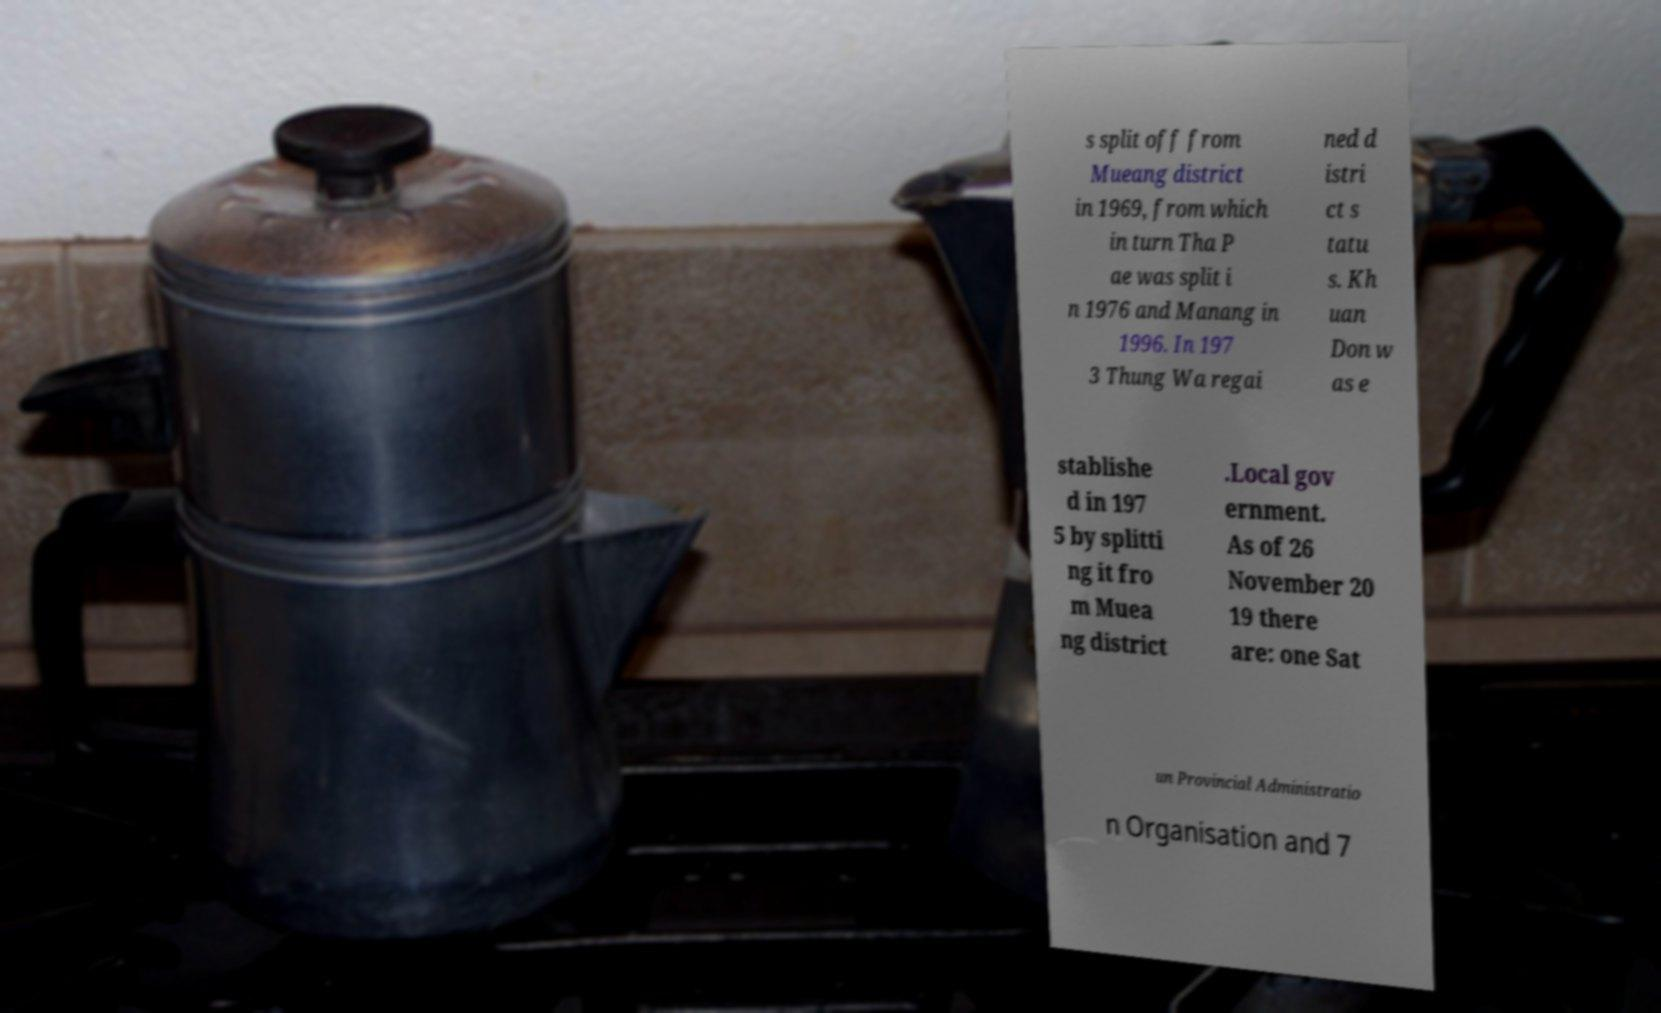Can you accurately transcribe the text from the provided image for me? s split off from Mueang district in 1969, from which in turn Tha P ae was split i n 1976 and Manang in 1996. In 197 3 Thung Wa regai ned d istri ct s tatu s. Kh uan Don w as e stablishe d in 197 5 by splitti ng it fro m Muea ng district .Local gov ernment. As of 26 November 20 19 there are: one Sat un Provincial Administratio n Organisation and 7 